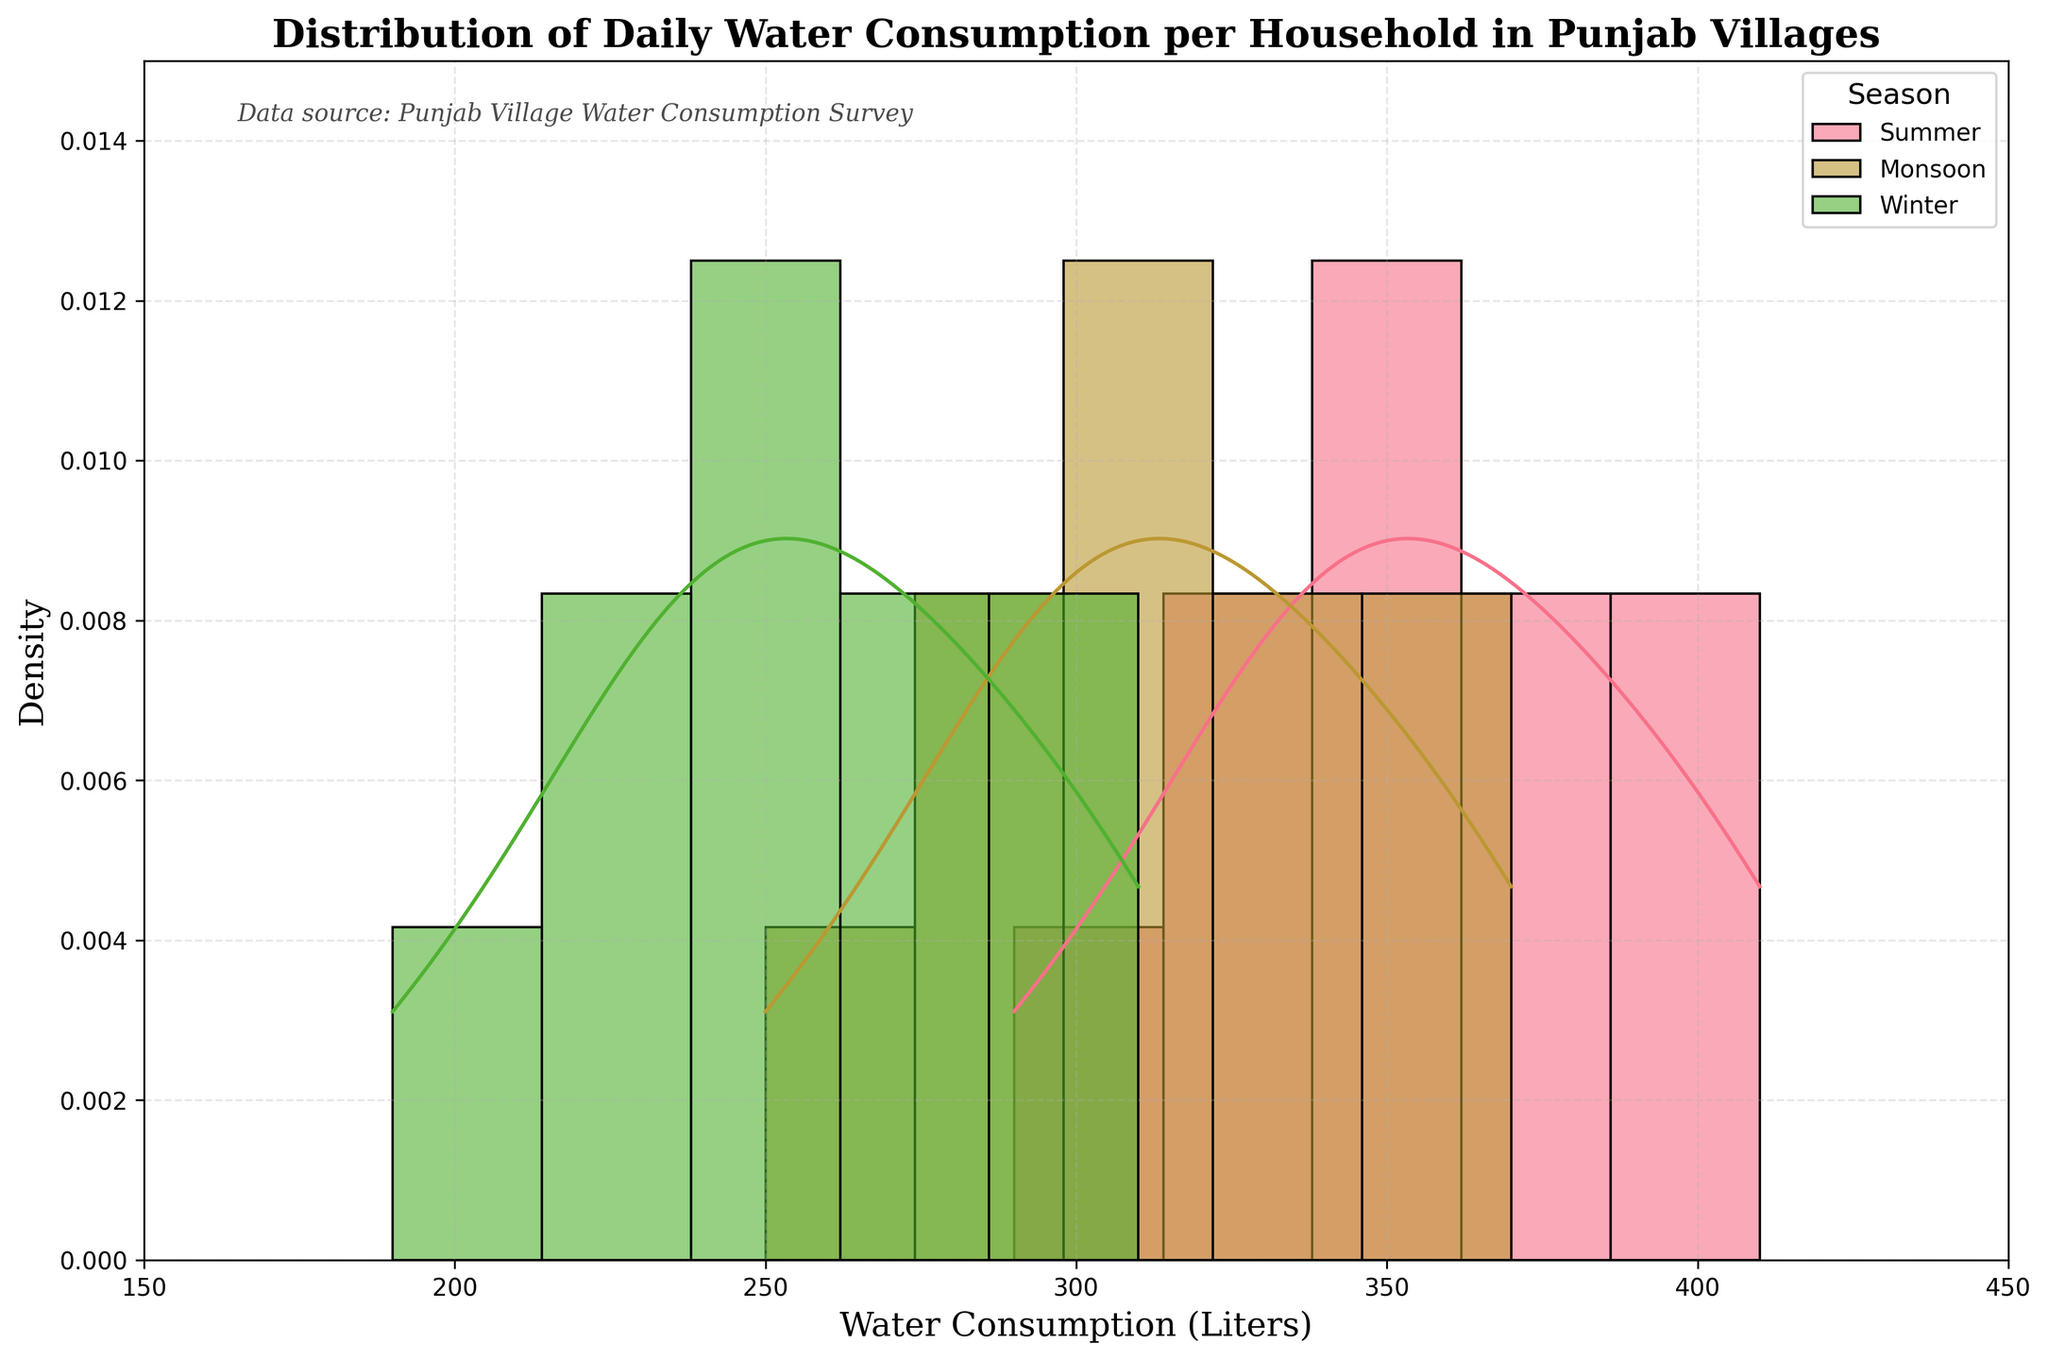What is the title of the histogram? The title is usually displayed at the top of the histogram. In the given plot, it reads: "Distribution of Daily Water Consumption per Household in Punjab Villages".
Answer: Distribution of Daily Water Consumption per Household in Punjab Villages Which axis represents water consumption? The x-axis typically portrays the variable being measured. Here, it is labeled "Water Consumption (Liters)".
Answer: x-axis What is the range of water consumption shown on the x-axis? The x-axis limits are shown from left to right. Based on the given plot, it ranges from 150 to 450 liters.
Answer: 150 to 450 liters Which season shows the highest density peak in water consumption? Observing the KDE (density curve) for each season, the curve with the highest peak indicates the season with the highest density. For this data, Summer shows the highest peak.
Answer: Summer Compare the density peaks for Summer and Winter seasons. Which season has a higher peak and where are they located? By comparing the KDE curves, the height and location of the peaks can be evaluated. The Summer peak is higher and located around 370-380 liters, while the Winter peak is lower and around 260-270 liters.
Answer: Summer; around 370-380 liters What can be inferred about water consumption in the Monsoon season compared to Winter? To infer the comparison, one should note the KDE curve height and spread. Monsoon's density peak is higher and located around 300-320 liters, indicating higher and more consistent water consumption compared to Winter.
Answer: Monsoon's is higher, around 300-320 liters What is the approximate density for water consumption at 250 liters in Winter? Locate the 250-liter mark on the x-axis and trace upwards to the KDE curve for Winter to find the corresponding density value. It appears to be approximately 0.013.
Answer: 0.013 Which season shows the broadest distribution of water consumption? The KDE curve width indicates the distribution spread; a broader curve means a wider distribution. The Monsoon season has the broadest distribution, as its curve extends across more x-axis values.
Answer: Monsoon How does the water consumption in Summer compare to Monsoon around 350 liters? Compare the KDE curve heights for both seasons at the 350-liter mark. Summer shows a higher density than Monsoon at this point.
Answer: Summer has a higher density at 350 liters 